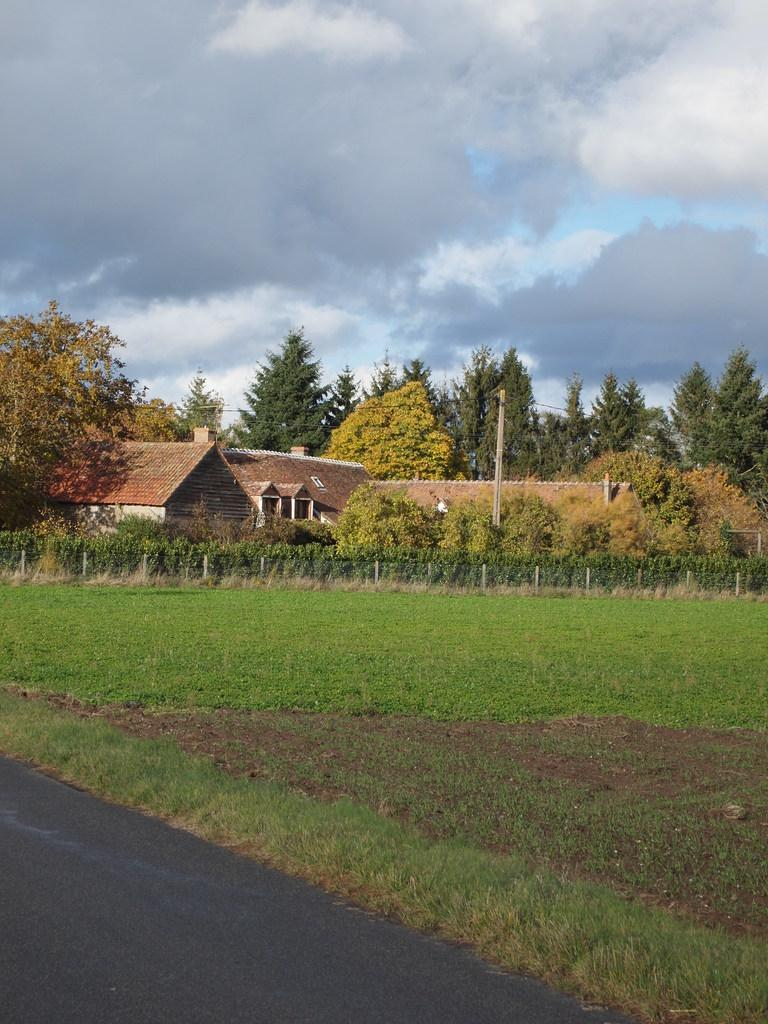What type of landscape is visible at the bottom of the image? There is grassland at the bottom side of the image. What structures can be seen in the center of the image? There are houses in the center of the image. What type of vegetation is present in the center of the image? There are trees in the center of the image. Where is the cream being poured in the image? There is no cream being poured in the image. Is there a volcano visible in the image? No, there is no volcano present in the image. 